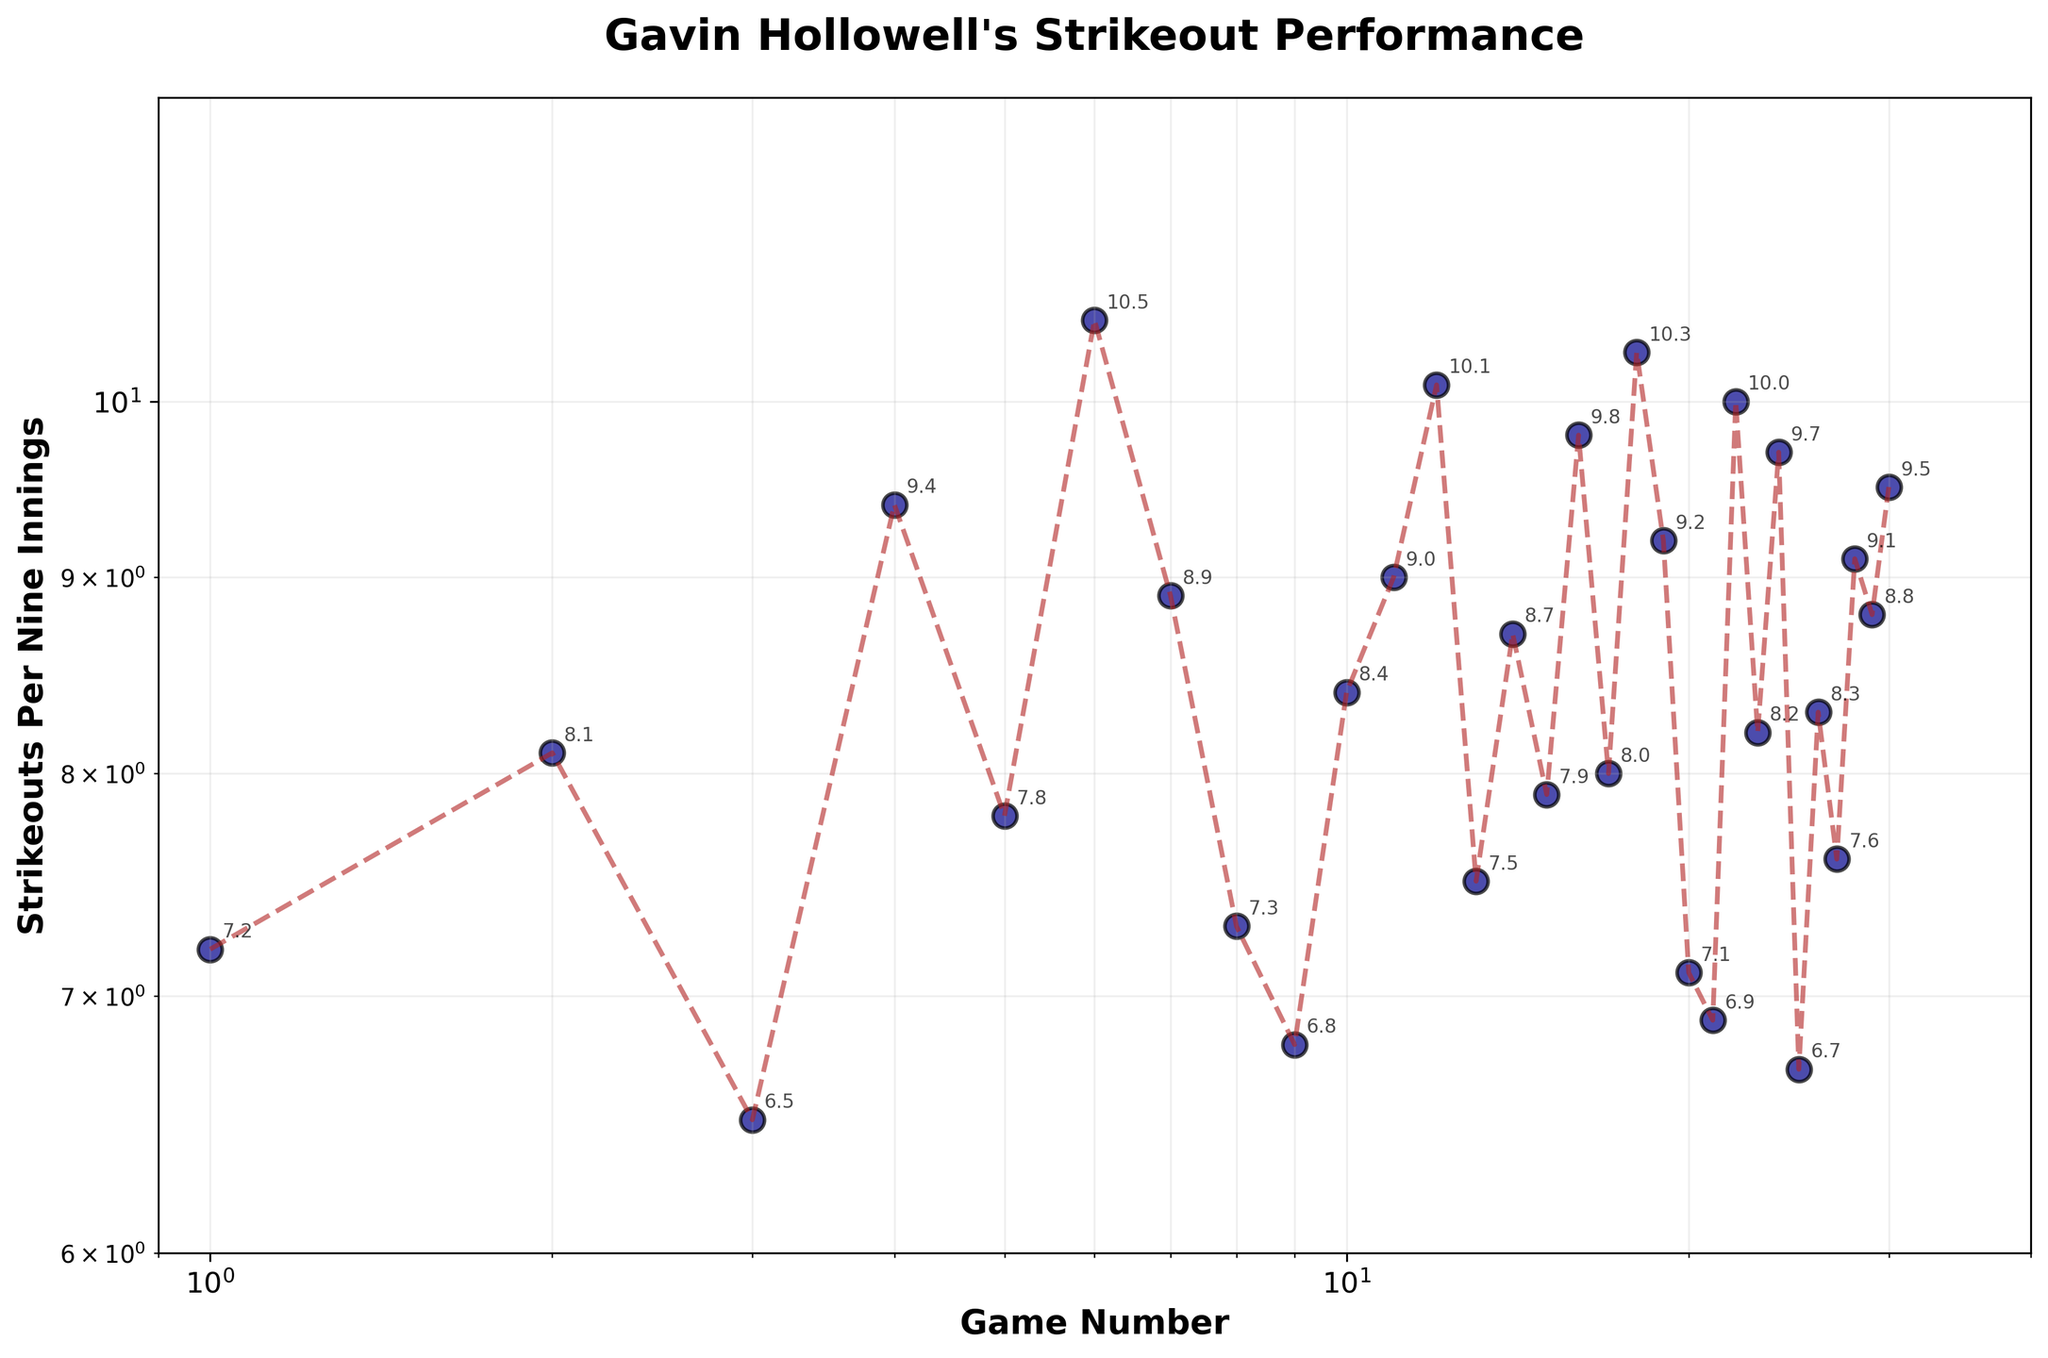What is the title of the figure? The title is the large, bold text at the top of the figure. It describes what the graph is about.
Answer: Gavin Hollowell's Strikeout Performance Which axis represents the game number? The horizontal axis (x-axis) shows the Game Number as it is labeled directly below it.
Answer: x-axis What is the strikeouts per nine innings in Game 15? Locate Game 15 on the x-axis and follow it up to the data point. Read the value on the y-axis.
Answer: 7.9 How does the strikeout rate in Game 7 compare to Game 14? Compare y-axis values at Game 7 and Game 14. Game 7 has a strikeout rate of 8.9, while Game 14 is 8.7.
Answer: Game 7 is higher What is the range of strikeouts per nine innings displayed in the figure? Subtract the smallest strikeout rate (Game 1, 6.7) from the largest (Game 6, 10.5).
Answer: 6.7 - 10.5 What logarithmic scales are used for the axes? The figure's x-axis and y-axis labels are both noted with "log" scales with respective ranges visible.
Answer: Both x-axis and y-axis Which game has the highest strikeouts per nine innings? Identify the highest y-value data point, which is Game 6 at 10.5.
Answer: Game 6 What is the sum of strikeout rates for Game 2 and Game 18? Sum strikeout rates: 8.1 (Game 2) + 10.3 (Game 18).
Answer: 18.4 Which game has the lowest strikeouts per nine innings? Identify the lowest y-value data point, which is Game 1 at 6.7.
Answer: Game 1 What is the average strikeouts per nine innings for the first five games? Calculate the averages: (7.2 + 8.1 + 6.5 + 9.4 + 7.8) / 5.
Answer: 7.8 